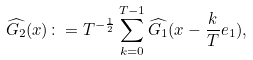<formula> <loc_0><loc_0><loc_500><loc_500>\widehat { G _ { 2 } } ( x ) \colon = T ^ { - \frac { 1 } { 2 } } \sum ^ { T - 1 } _ { k = 0 } \widehat { G _ { 1 } } ( x - \frac { k } { T } e _ { 1 } ) ,</formula> 